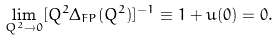<formula> <loc_0><loc_0><loc_500><loc_500>\lim _ { Q ^ { 2 } \rightarrow 0 } [ Q ^ { 2 } \Delta _ { F P } ( Q ^ { 2 } ) ] ^ { - 1 } \equiv 1 + u ( 0 ) = 0 .</formula> 